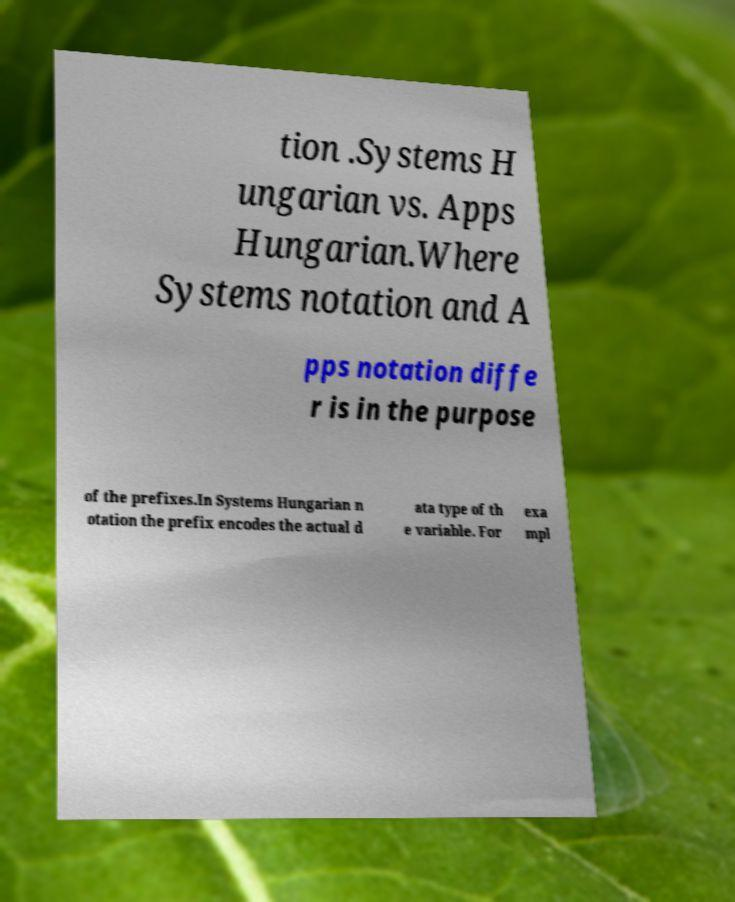What messages or text are displayed in this image? I need them in a readable, typed format. tion .Systems H ungarian vs. Apps Hungarian.Where Systems notation and A pps notation diffe r is in the purpose of the prefixes.In Systems Hungarian n otation the prefix encodes the actual d ata type of th e variable. For exa mpl 